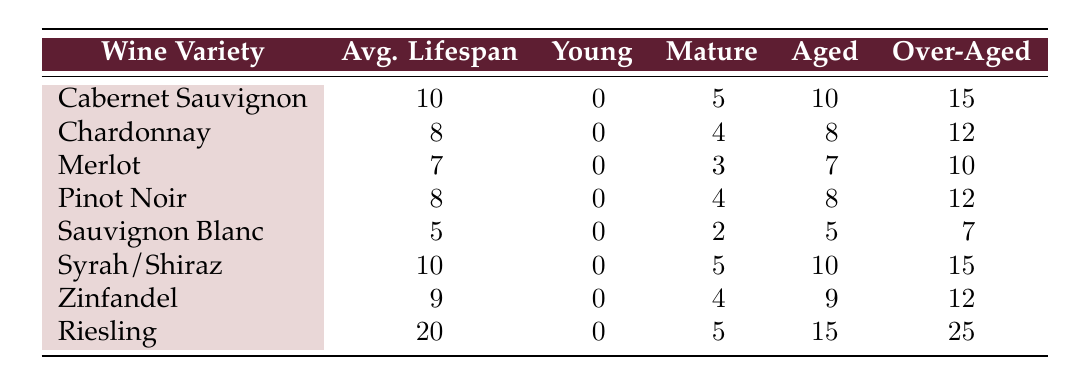What is the average lifespan of Riesling? The table shows that the average lifespan of Riesling is 20.
Answer: 20 Which wine variety has the longest average lifespan? By comparing the average lifespans listed in the table, Riesling has the longest average lifespan at 20.
Answer: Riesling How many categories of age are there for Cabernet Sauvignon? The table lists four age categories for Cabernet Sauvignon: young, mature, aged, and over-aged.
Answer: 4 Which wine variety has a lifespan of 7 years? The table directly indicates that Merlot has an average lifespan of 7 years.
Answer: Merlot If we add up the average lifespans of all wine varieties, what is the sum? The average lifespans are 10 (Cabernet Sauvignon) + 8 (Chardonnay) + 7 (Merlot) + 8 (Pinot Noir) + 5 (Sauvignon Blanc) + 10 (Syrah/Shiraz) + 9 (Zinfandel) + 20 (Riesling) = 77.
Answer: 77 Is it true that Sauvignon Blanc is categorized as aged at 5 years? Looking at the table, Sauvignon Blanc has an aged category listed as 5 years, confirming the statement is true.
Answer: Yes Which wine has a mature category age of 3 years? The table indicates that Merlot has a mature category age of 3 years.
Answer: Merlot What is the average lifespan of wines that fall into the "over-aged" category? The over-aged category ages are 15 (Cabernet Sauvignon), 12 (Chardonnay), 10 (Merlot), 12 (Pinot Noir), 7 (Sauvignon Blanc), 15 (Syrah/Shiraz), 12 (Zinfandel), and 25 (Riesling). The average is calculated as (15 + 12 + 10 + 12 + 7 + 15 + 12 + 25) / 8 = 14.375.
Answer: 14.375 Which wine has the same average lifespan as Chardonnay? Pinots Noir has the same average lifespan of 8 years as Chardonnay.
Answer: Pinot Noir 